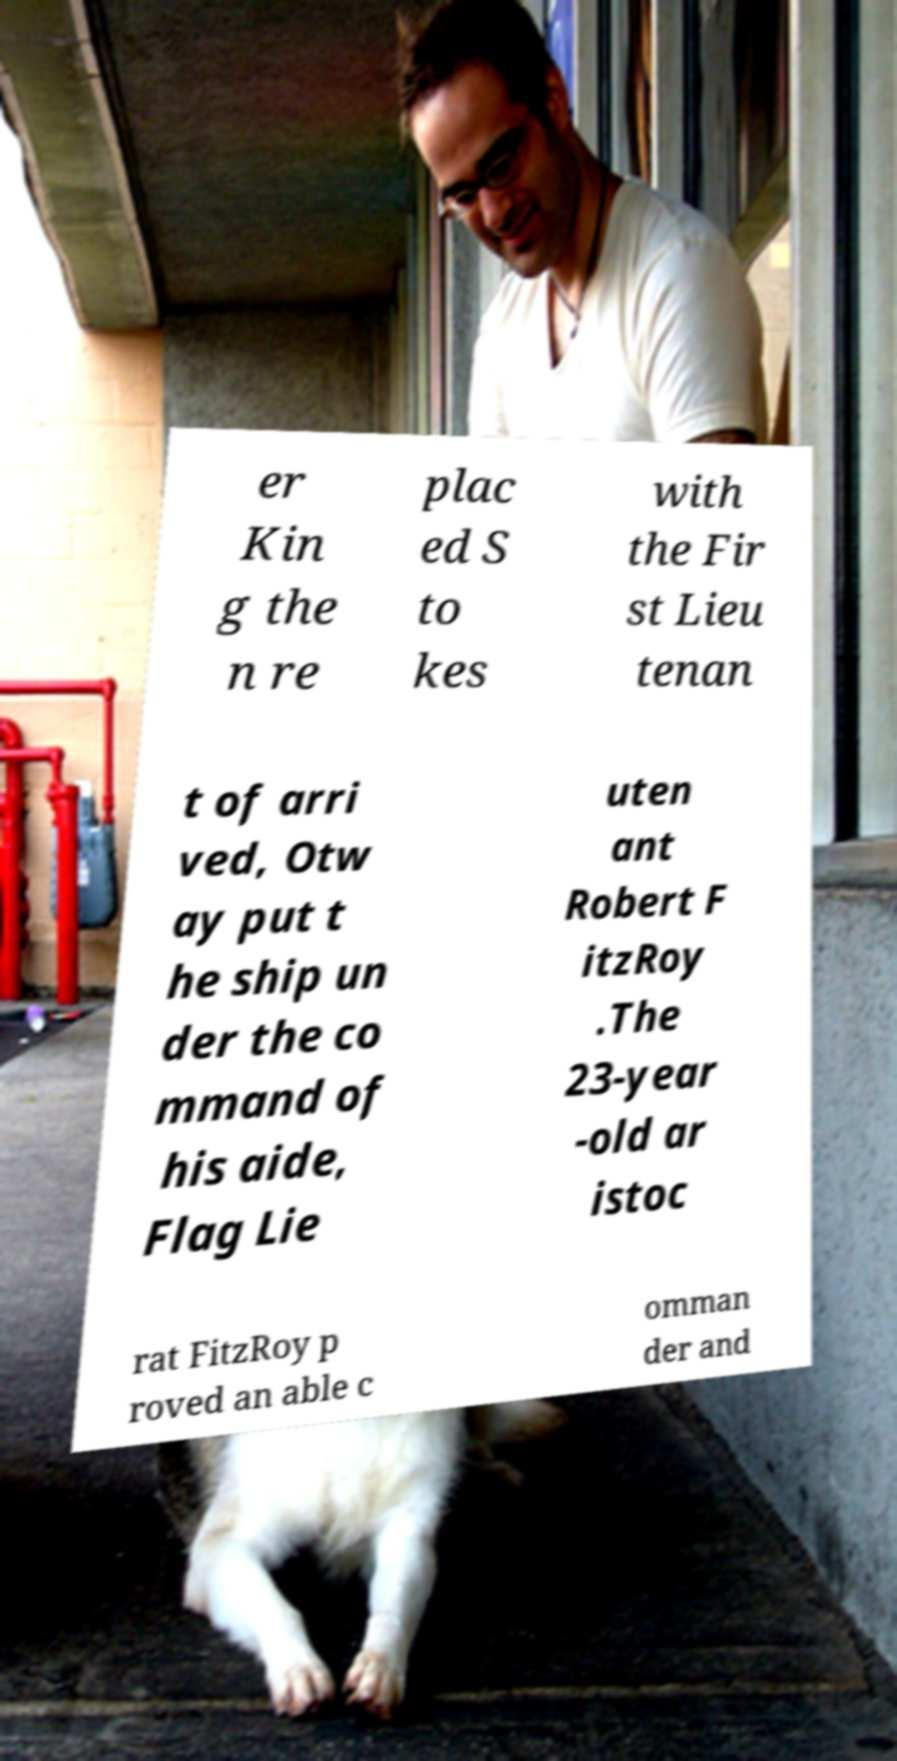Please identify and transcribe the text found in this image. er Kin g the n re plac ed S to kes with the Fir st Lieu tenan t of arri ved, Otw ay put t he ship un der the co mmand of his aide, Flag Lie uten ant Robert F itzRoy .The 23-year -old ar istoc rat FitzRoy p roved an able c omman der and 